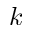<formula> <loc_0><loc_0><loc_500><loc_500>k</formula> 